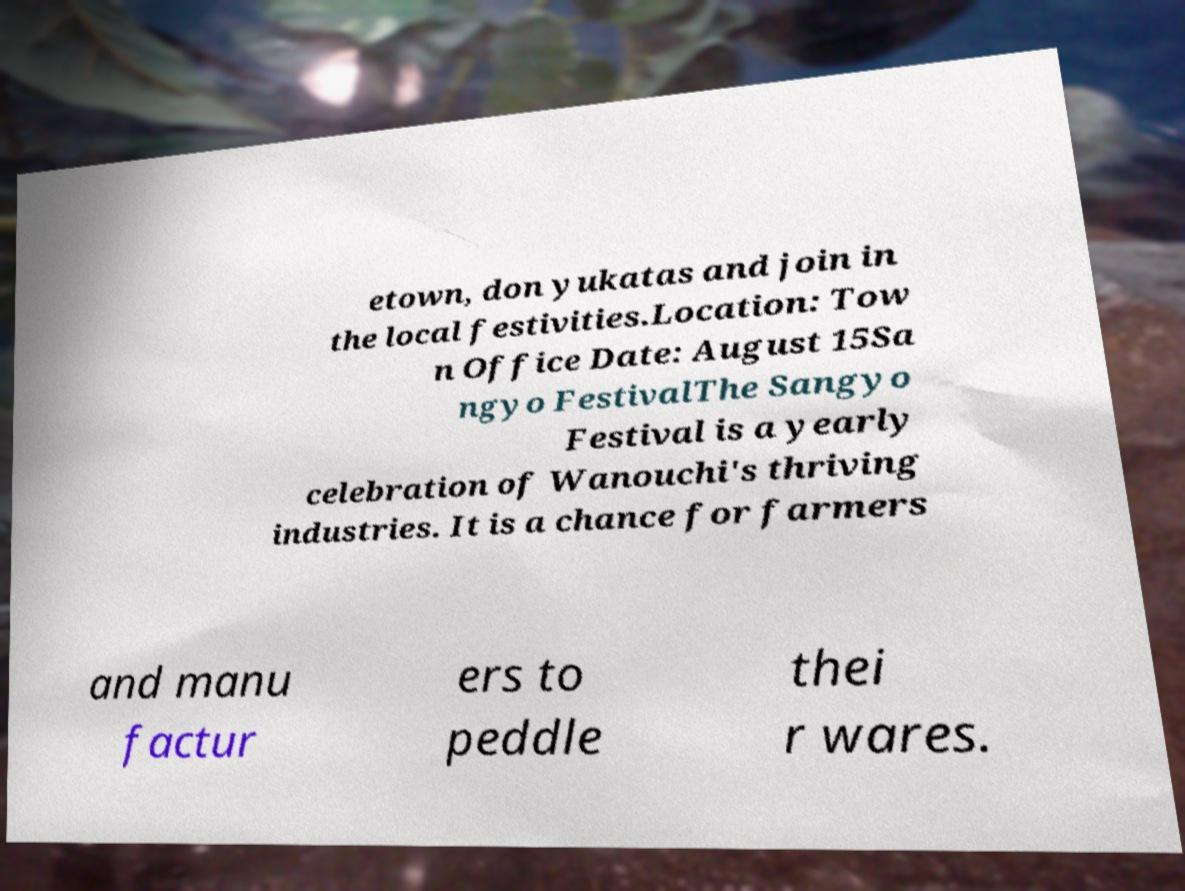I need the written content from this picture converted into text. Can you do that? etown, don yukatas and join in the local festivities.Location: Tow n Office Date: August 15Sa ngyo FestivalThe Sangyo Festival is a yearly celebration of Wanouchi's thriving industries. It is a chance for farmers and manu factur ers to peddle thei r wares. 